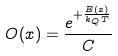<formula> <loc_0><loc_0><loc_500><loc_500>O ( x ) = \frac { e ^ { + \frac { E ( x ) } { k _ { Q } T } } } { C }</formula> 